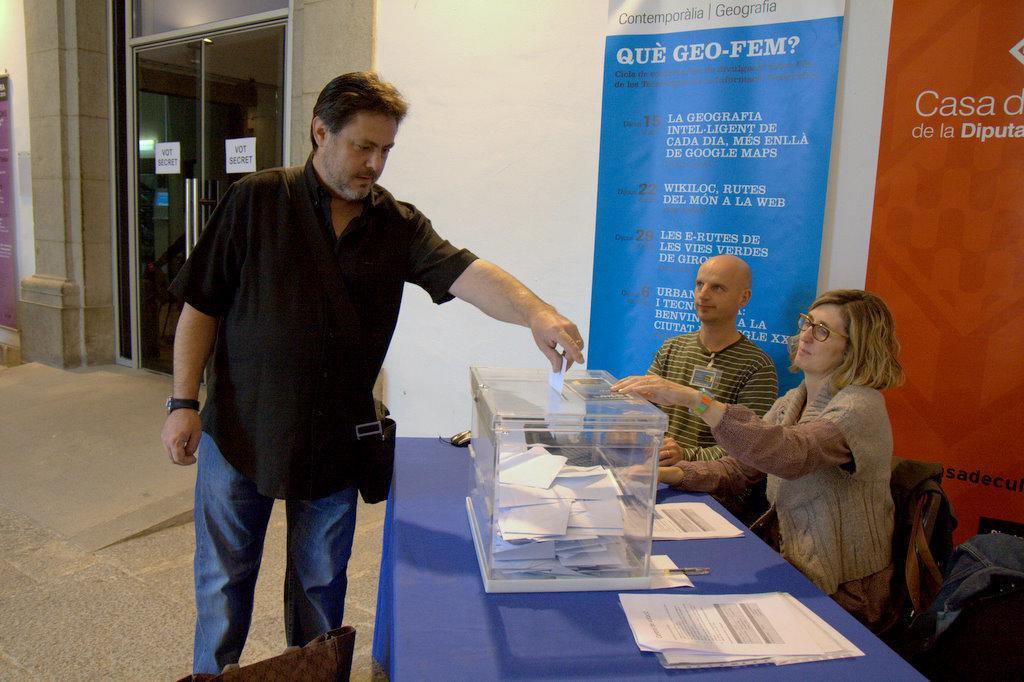In one or two sentences, can you explain what this image depicts? In this image we can see three persons, a person is standing, two of them are sitting on the chairs, there are few papers and a box with some papers on the table, there are banners with text near the wall and some posters attached to the door. 